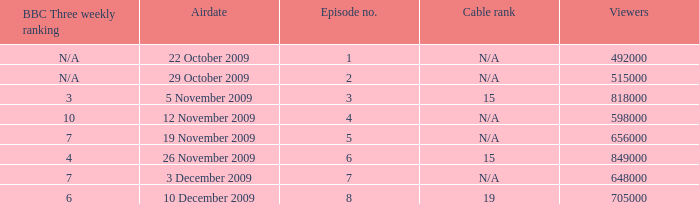How many viewers were there for airdate is 22 october 2009? 492000.0. 